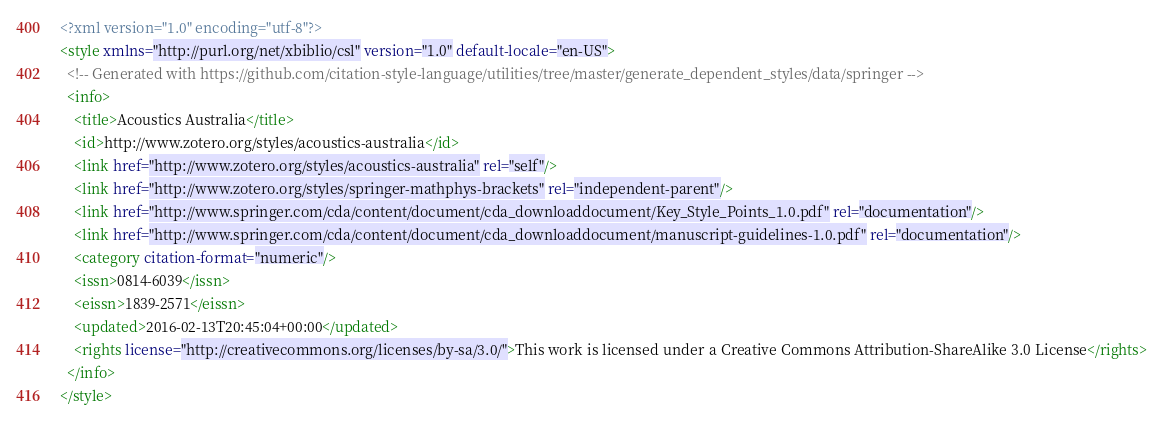Convert code to text. <code><loc_0><loc_0><loc_500><loc_500><_XML_><?xml version="1.0" encoding="utf-8"?>
<style xmlns="http://purl.org/net/xbiblio/csl" version="1.0" default-locale="en-US">
  <!-- Generated with https://github.com/citation-style-language/utilities/tree/master/generate_dependent_styles/data/springer -->
  <info>
    <title>Acoustics Australia</title>
    <id>http://www.zotero.org/styles/acoustics-australia</id>
    <link href="http://www.zotero.org/styles/acoustics-australia" rel="self"/>
    <link href="http://www.zotero.org/styles/springer-mathphys-brackets" rel="independent-parent"/>
    <link href="http://www.springer.com/cda/content/document/cda_downloaddocument/Key_Style_Points_1.0.pdf" rel="documentation"/>
    <link href="http://www.springer.com/cda/content/document/cda_downloaddocument/manuscript-guidelines-1.0.pdf" rel="documentation"/>
    <category citation-format="numeric"/>
    <issn>0814-6039</issn>
    <eissn>1839-2571</eissn>
    <updated>2016-02-13T20:45:04+00:00</updated>
    <rights license="http://creativecommons.org/licenses/by-sa/3.0/">This work is licensed under a Creative Commons Attribution-ShareAlike 3.0 License</rights>
  </info>
</style>
</code> 